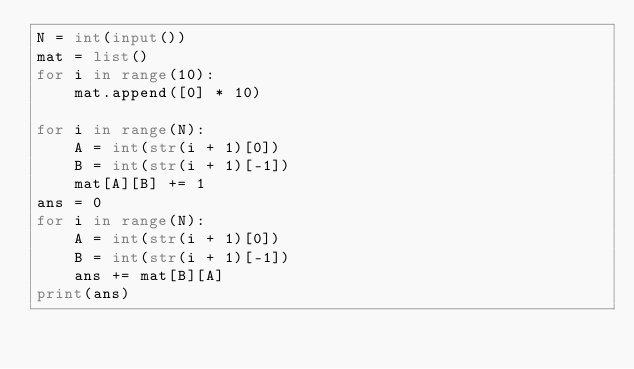Convert code to text. <code><loc_0><loc_0><loc_500><loc_500><_Python_>N = int(input())
mat = list()
for i in range(10):
    mat.append([0] * 10)

for i in range(N):
    A = int(str(i + 1)[0])
    B = int(str(i + 1)[-1])
    mat[A][B] += 1
ans = 0
for i in range(N):
    A = int(str(i + 1)[0])
    B = int(str(i + 1)[-1])
    ans += mat[B][A]
print(ans)
</code> 